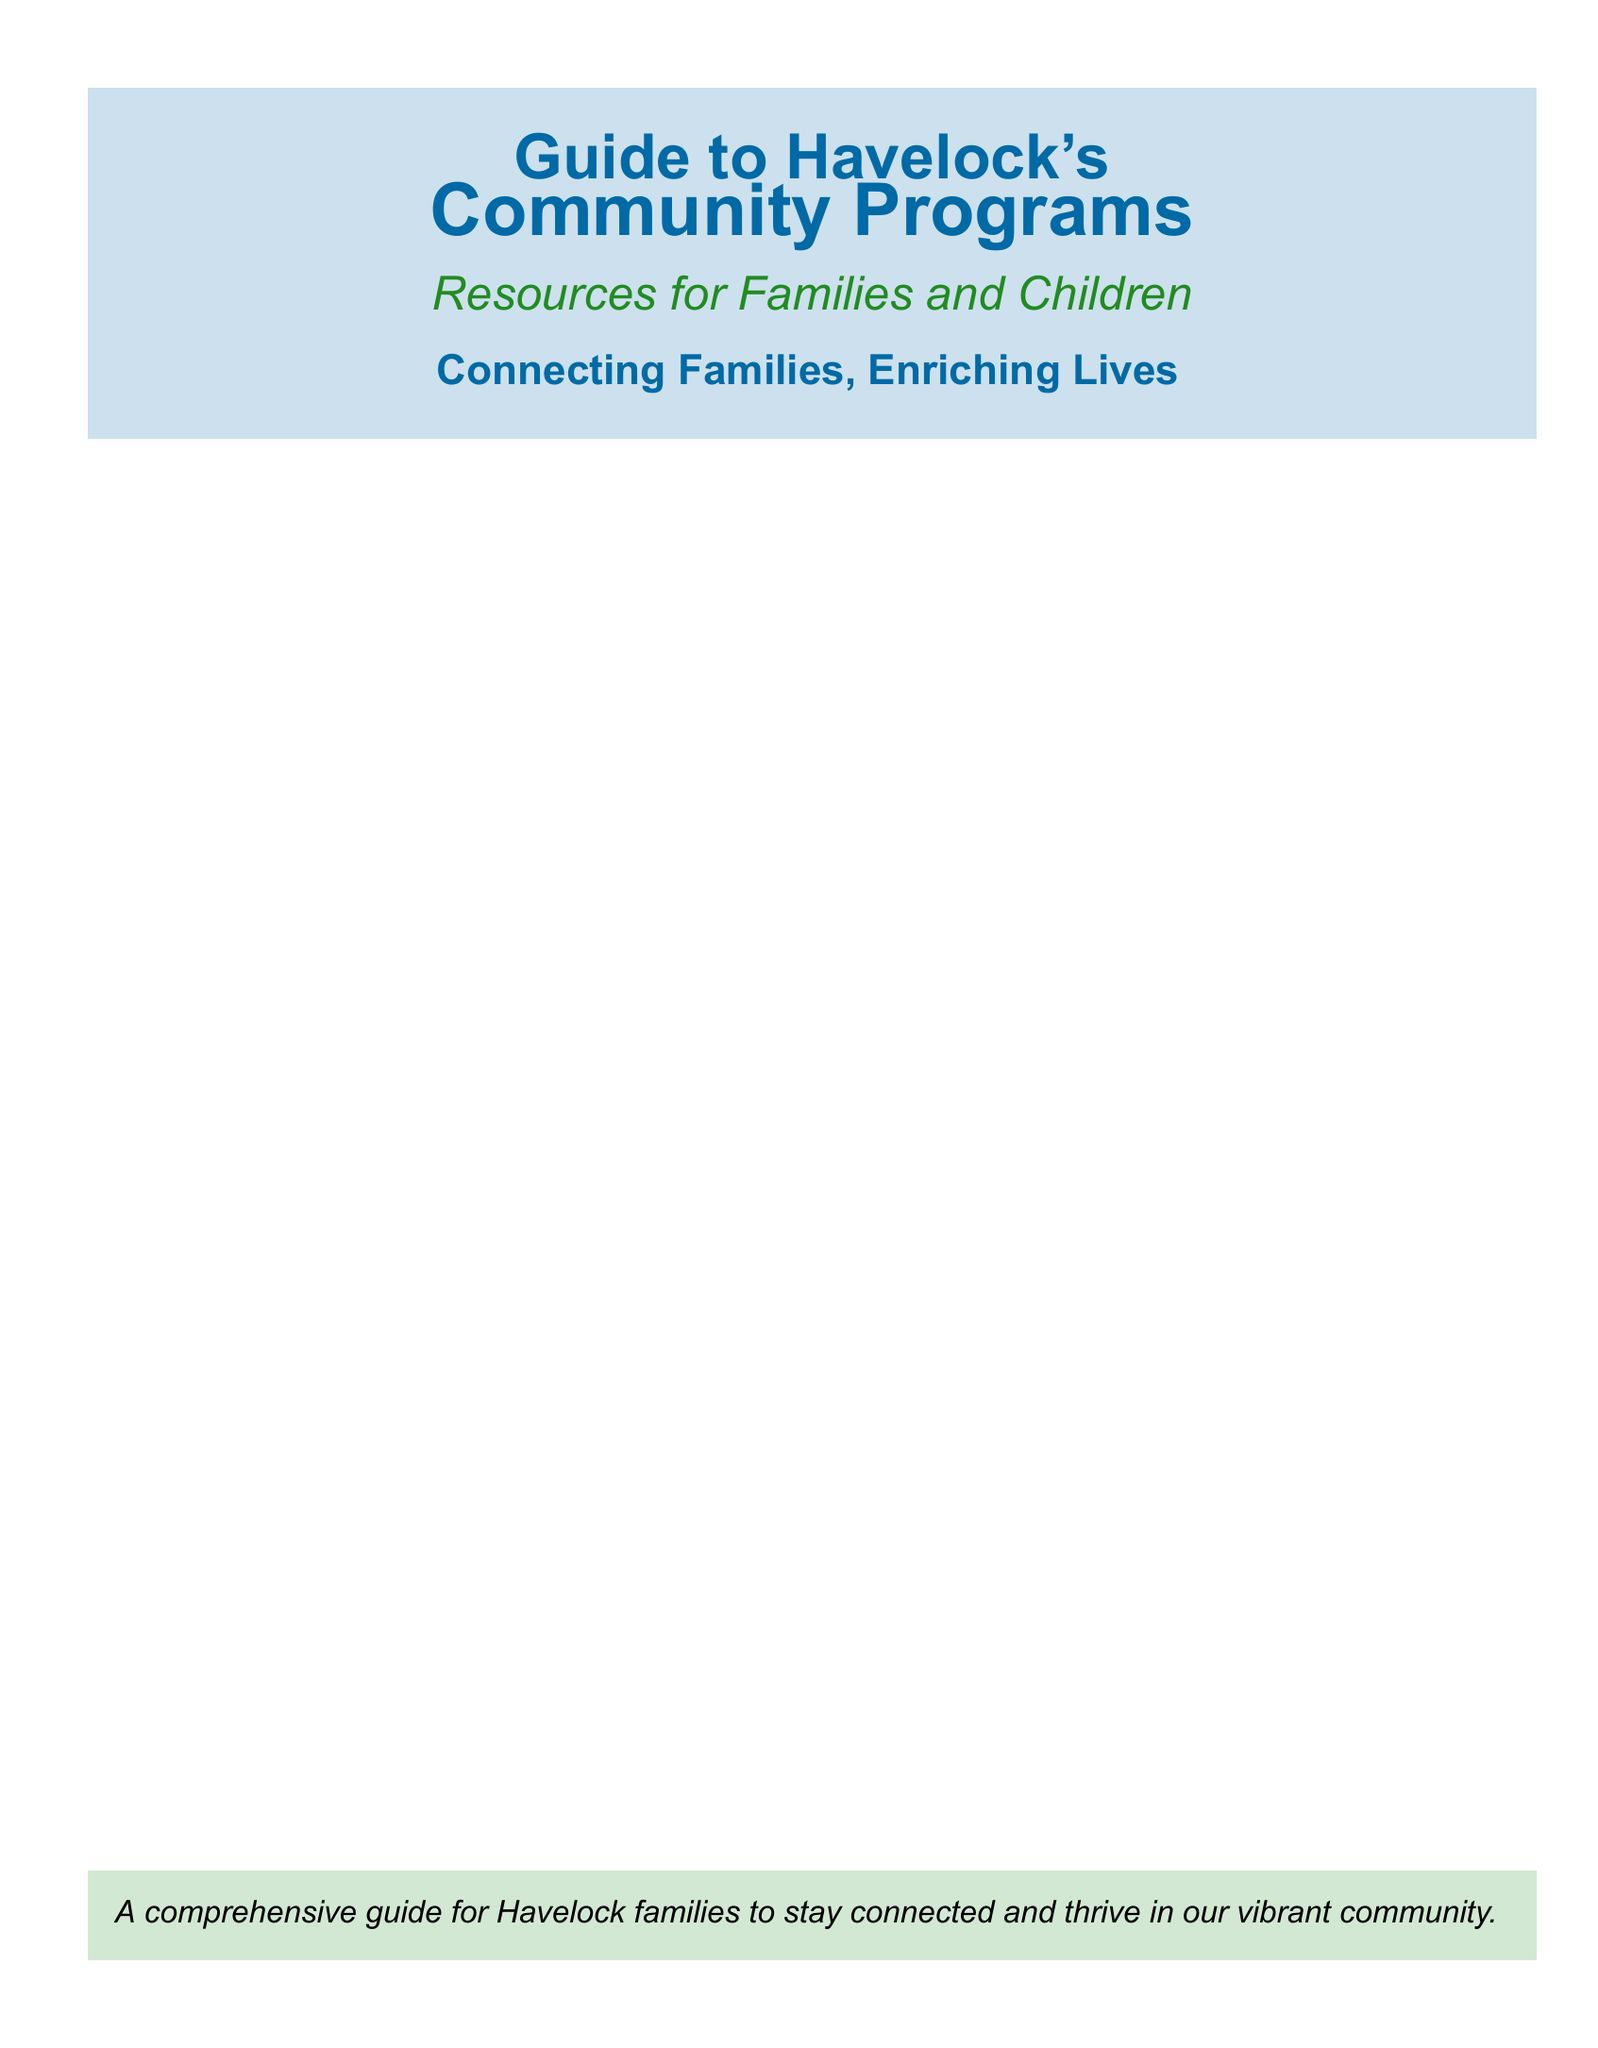What is the title of the guide? The title is indicated prominently in the document's header section.
Answer: Guide to Havelock's Community Programs How many main sections are listed in the document? The document features three main sections of community focus: Community Programs, Local Activities, and Support Services.
Answer: Three What is one of the local activities mentioned? The document lists multiple local activities aimed at families, available under the Local Activities section.
Answer: Annual Havelock Family Festival Which center provides resources for families? The document specifies this resource center in the Community Programs section, focusing on family support.
Answer: Havelock Family Resource Center What kind of activities are connected to nature? This question relates to the specific offerings within the Local Activities section of the guide.
Answer: Nature Walks at Croatan National Forest What is emphasized as a goal of the guide? The guide's goal is expressed as a succinct phrase in the footer area of the document.
Answer: Connecting Families, Enriching Lives 